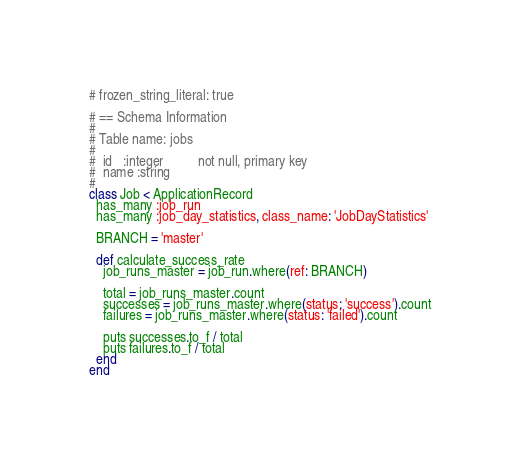Convert code to text. <code><loc_0><loc_0><loc_500><loc_500><_Ruby_># frozen_string_literal: true

# == Schema Information
#
# Table name: jobs
#
#  id   :integer          not null, primary key
#  name :string
#
class Job < ApplicationRecord
  has_many :job_run
  has_many :job_day_statistics, class_name: 'JobDayStatistics'

  BRANCH = 'master'

  def calculate_success_rate
    job_runs_master = job_run.where(ref: BRANCH)

    total = job_runs_master.count
    successes = job_runs_master.where(status: 'success').count
    failures = job_runs_master.where(status: 'failed').count

    puts successes.to_f / total
    puts failures.to_f / total
  end
end
</code> 